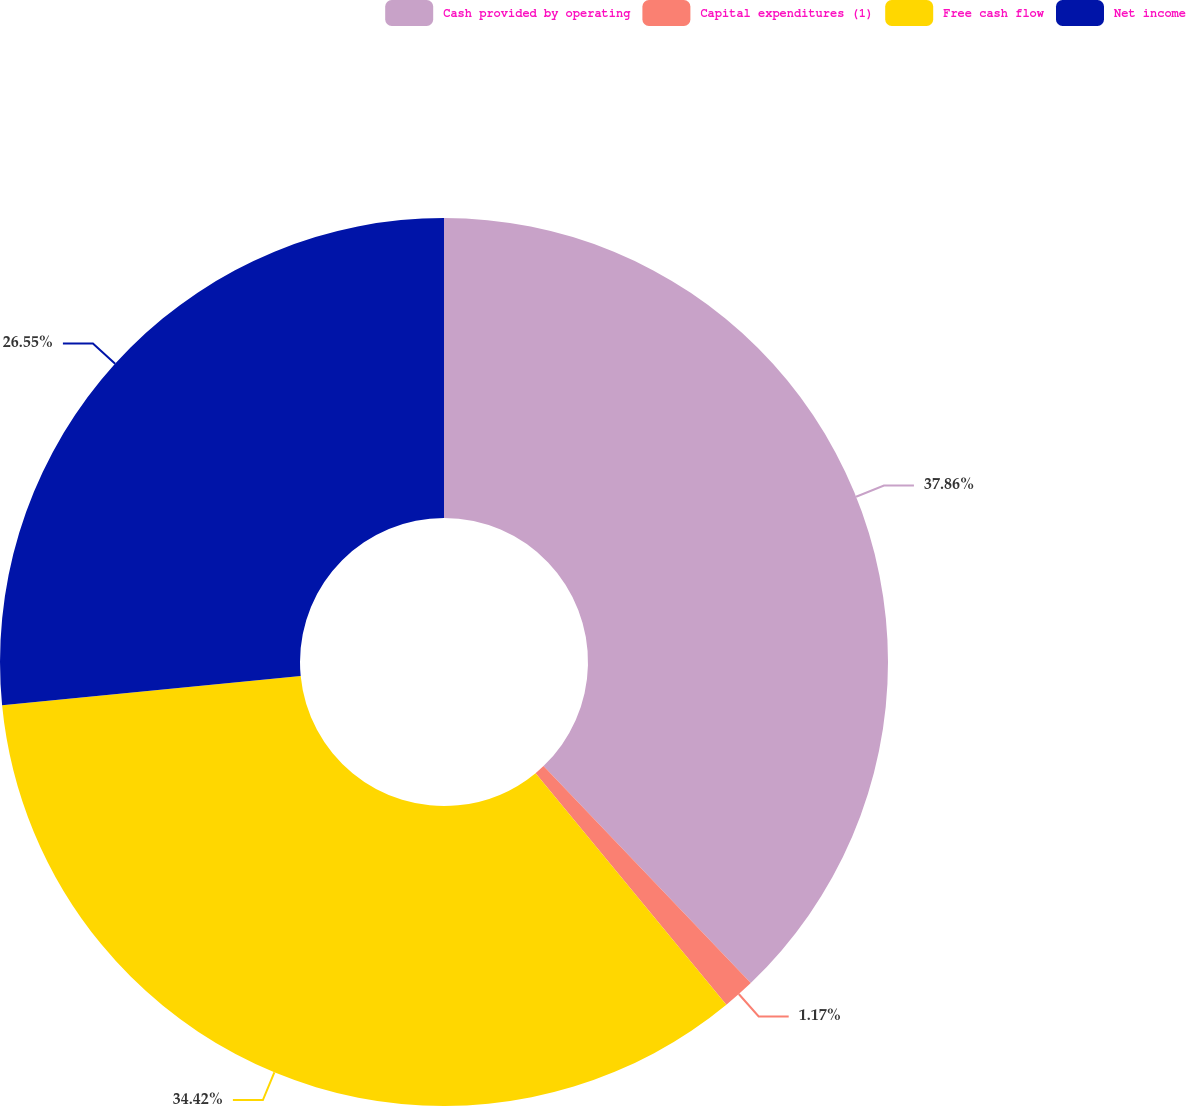Convert chart. <chart><loc_0><loc_0><loc_500><loc_500><pie_chart><fcel>Cash provided by operating<fcel>Capital expenditures (1)<fcel>Free cash flow<fcel>Net income<nl><fcel>37.86%<fcel>1.17%<fcel>34.42%<fcel>26.55%<nl></chart> 